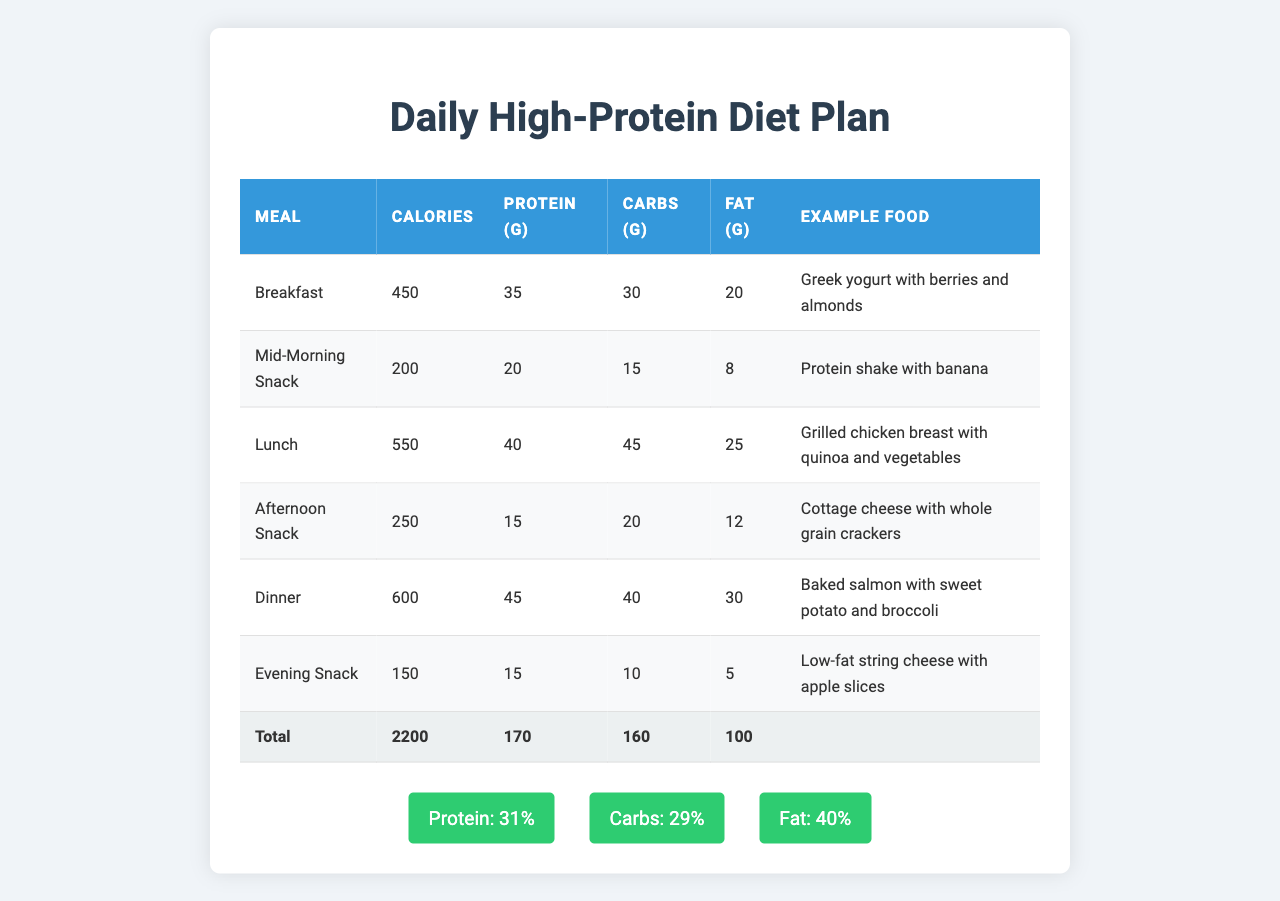What is the total calorie count for the day? By looking at the table in the "Total" row under "Calories," we find that the total is 2200.
Answer: 2200 How much protein is consumed at lunch? In the "Lunch" row, the protein amount is listed under "Protein (g)," showing a value of 40 grams.
Answer: 40 grams What is the total amount of fat consumed in the diet plan? The "Total" row under "Fat (g)" shows a sum of 100 grams for the entire day.
Answer: 100 grams Which meal has the highest protein content? From the table, the "Dinner" meal has the highest protein, which is 45 grams.
Answer: Dinner What percentage of total calories comes from protein? We see from the "macronutrient percentages" section that protein constitutes 31% of total calories.
Answer: 31% How many carbs are consumed in the afternoon snack? Referring to the "Afternoon Snack" row, it is stated that there are 20 grams of carbs.
Answer: 20 grams If one wanted to reduce fat to 30 grams for the day, how much fat would they need to cut? The total fat is 100 grams; to achieve a goal of 30 grams, they would need to cut 100 - 30 = 70 grams.
Answer: 70 grams Which meal has fewer calories: breakfast or mid-morning snack? Breakfast has 450 calories while the mid-morning snack has 200 calories. Since 200 is less than 450, the mid-morning snack has fewer calories.
Answer: Mid-Morning Snack What is the average protein intake across all meals? Total protein is 170 grams; there are 6 meals, so the average is 170/6 = approximately 28.33 grams.
Answer: 28.33 grams Is it true that the evening snack has more calories than the mid-morning snack? The evening snack has 150 calories and the mid-morning snack has 200 calories, so it is false that the evening snack has more.
Answer: False How many more carbs does lunch have compared to breakfast? Lunch has 45 grams of carbs and breakfast has 30 grams. The difference is 45 - 30 = 15 grams more in lunch.
Answer: 15 grams What meal provides the least protein? The "Afternoon Snack" provides the least protein at 15 grams.
Answer: Afternoon Snack 